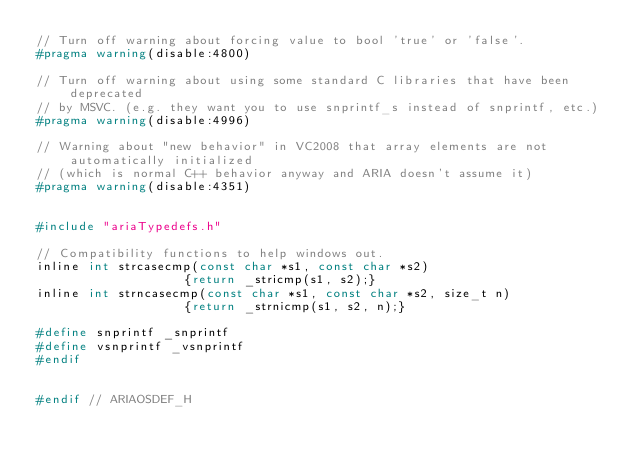<code> <loc_0><loc_0><loc_500><loc_500><_C_>// Turn off warning about forcing value to bool 'true' or 'false'.
#pragma warning(disable:4800)

// Turn off warning about using some standard C libraries that have been deprecated
// by MSVC. (e.g. they want you to use snprintf_s instead of snprintf, etc.)
#pragma warning(disable:4996)

// Warning about "new behavior" in VC2008 that array elements are not automatically initialized 
// (which is normal C++ behavior anyway and ARIA doesn't assume it)
#pragma warning(disable:4351)


#include "ariaTypedefs.h"

// Compatibility functions to help windows out.
inline int strcasecmp(const char *s1, const char *s2) 
                    {return _stricmp(s1, s2);}
inline int strncasecmp(const char *s1, const char *s2, size_t n) 
                    {return _strnicmp(s1, s2, n);}

#define snprintf _snprintf
#define vsnprintf _vsnprintf
#endif


#endif // ARIAOSDEF_H
</code> 